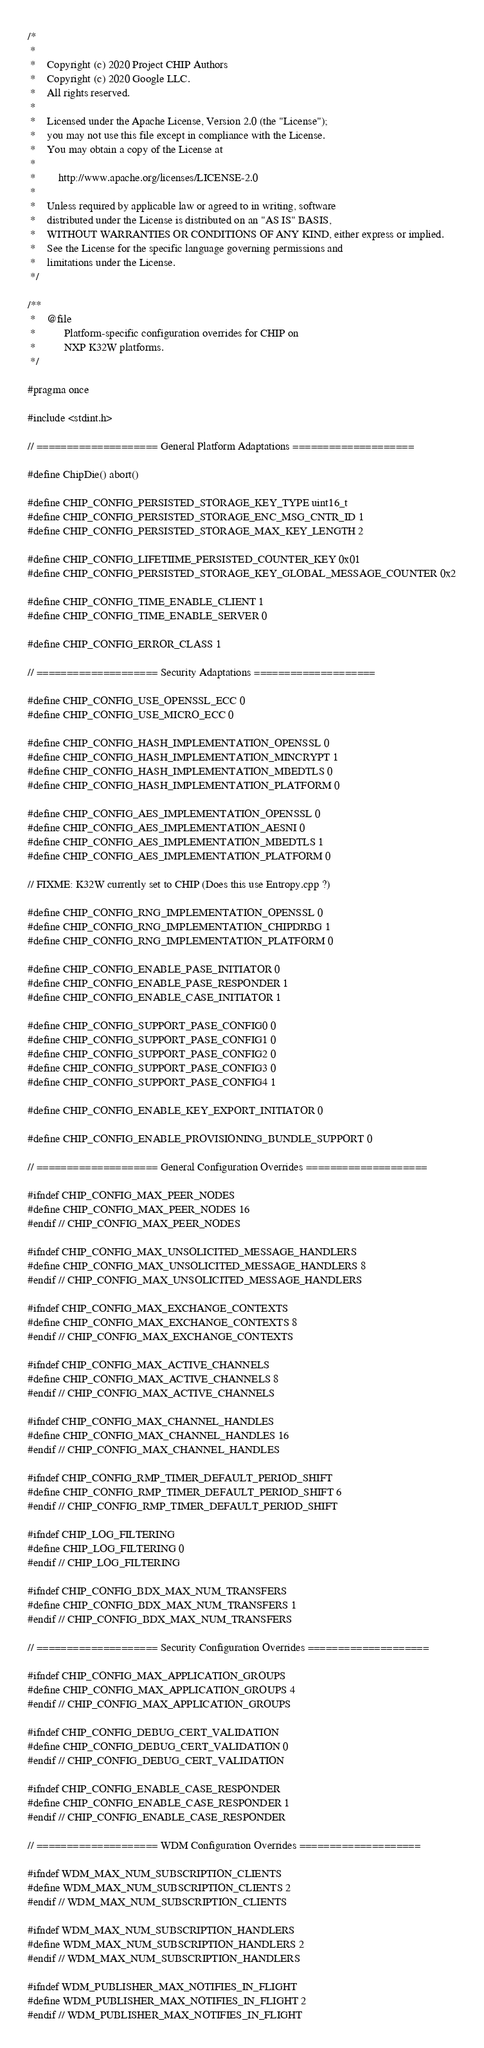<code> <loc_0><loc_0><loc_500><loc_500><_C_>/*
 *
 *    Copyright (c) 2020 Project CHIP Authors
 *    Copyright (c) 2020 Google LLC.
 *    All rights reserved.
 *
 *    Licensed under the Apache License, Version 2.0 (the "License");
 *    you may not use this file except in compliance with the License.
 *    You may obtain a copy of the License at
 *
 *        http://www.apache.org/licenses/LICENSE-2.0
 *
 *    Unless required by applicable law or agreed to in writing, software
 *    distributed under the License is distributed on an "AS IS" BASIS,
 *    WITHOUT WARRANTIES OR CONDITIONS OF ANY KIND, either express or implied.
 *    See the License for the specific language governing permissions and
 *    limitations under the License.
 */

/**
 *    @file
 *          Platform-specific configuration overrides for CHIP on
 *          NXP K32W platforms.
 */

#pragma once

#include <stdint.h>

// ==================== General Platform Adaptations ====================

#define ChipDie() abort()

#define CHIP_CONFIG_PERSISTED_STORAGE_KEY_TYPE uint16_t
#define CHIP_CONFIG_PERSISTED_STORAGE_ENC_MSG_CNTR_ID 1
#define CHIP_CONFIG_PERSISTED_STORAGE_MAX_KEY_LENGTH 2

#define CHIP_CONFIG_LIFETIIME_PERSISTED_COUNTER_KEY 0x01
#define CHIP_CONFIG_PERSISTED_STORAGE_KEY_GLOBAL_MESSAGE_COUNTER 0x2

#define CHIP_CONFIG_TIME_ENABLE_CLIENT 1
#define CHIP_CONFIG_TIME_ENABLE_SERVER 0

#define CHIP_CONFIG_ERROR_CLASS 1

// ==================== Security Adaptations ====================

#define CHIP_CONFIG_USE_OPENSSL_ECC 0
#define CHIP_CONFIG_USE_MICRO_ECC 0

#define CHIP_CONFIG_HASH_IMPLEMENTATION_OPENSSL 0
#define CHIP_CONFIG_HASH_IMPLEMENTATION_MINCRYPT 1
#define CHIP_CONFIG_HASH_IMPLEMENTATION_MBEDTLS 0
#define CHIP_CONFIG_HASH_IMPLEMENTATION_PLATFORM 0

#define CHIP_CONFIG_AES_IMPLEMENTATION_OPENSSL 0
#define CHIP_CONFIG_AES_IMPLEMENTATION_AESNI 0
#define CHIP_CONFIG_AES_IMPLEMENTATION_MBEDTLS 1
#define CHIP_CONFIG_AES_IMPLEMENTATION_PLATFORM 0

// FIXME: K32W currently set to CHIP (Does this use Entropy.cpp ?)

#define CHIP_CONFIG_RNG_IMPLEMENTATION_OPENSSL 0
#define CHIP_CONFIG_RNG_IMPLEMENTATION_CHIPDRBG 1
#define CHIP_CONFIG_RNG_IMPLEMENTATION_PLATFORM 0

#define CHIP_CONFIG_ENABLE_PASE_INITIATOR 0
#define CHIP_CONFIG_ENABLE_PASE_RESPONDER 1
#define CHIP_CONFIG_ENABLE_CASE_INITIATOR 1

#define CHIP_CONFIG_SUPPORT_PASE_CONFIG0 0
#define CHIP_CONFIG_SUPPORT_PASE_CONFIG1 0
#define CHIP_CONFIG_SUPPORT_PASE_CONFIG2 0
#define CHIP_CONFIG_SUPPORT_PASE_CONFIG3 0
#define CHIP_CONFIG_SUPPORT_PASE_CONFIG4 1

#define CHIP_CONFIG_ENABLE_KEY_EXPORT_INITIATOR 0

#define CHIP_CONFIG_ENABLE_PROVISIONING_BUNDLE_SUPPORT 0

// ==================== General Configuration Overrides ====================

#ifndef CHIP_CONFIG_MAX_PEER_NODES
#define CHIP_CONFIG_MAX_PEER_NODES 16
#endif // CHIP_CONFIG_MAX_PEER_NODES

#ifndef CHIP_CONFIG_MAX_UNSOLICITED_MESSAGE_HANDLERS
#define CHIP_CONFIG_MAX_UNSOLICITED_MESSAGE_HANDLERS 8
#endif // CHIP_CONFIG_MAX_UNSOLICITED_MESSAGE_HANDLERS

#ifndef CHIP_CONFIG_MAX_EXCHANGE_CONTEXTS
#define CHIP_CONFIG_MAX_EXCHANGE_CONTEXTS 8
#endif // CHIP_CONFIG_MAX_EXCHANGE_CONTEXTS

#ifndef CHIP_CONFIG_MAX_ACTIVE_CHANNELS
#define CHIP_CONFIG_MAX_ACTIVE_CHANNELS 8
#endif // CHIP_CONFIG_MAX_ACTIVE_CHANNELS

#ifndef CHIP_CONFIG_MAX_CHANNEL_HANDLES
#define CHIP_CONFIG_MAX_CHANNEL_HANDLES 16
#endif // CHIP_CONFIG_MAX_CHANNEL_HANDLES

#ifndef CHIP_CONFIG_RMP_TIMER_DEFAULT_PERIOD_SHIFT
#define CHIP_CONFIG_RMP_TIMER_DEFAULT_PERIOD_SHIFT 6
#endif // CHIP_CONFIG_RMP_TIMER_DEFAULT_PERIOD_SHIFT

#ifndef CHIP_LOG_FILTERING
#define CHIP_LOG_FILTERING 0
#endif // CHIP_LOG_FILTERING

#ifndef CHIP_CONFIG_BDX_MAX_NUM_TRANSFERS
#define CHIP_CONFIG_BDX_MAX_NUM_TRANSFERS 1
#endif // CHIP_CONFIG_BDX_MAX_NUM_TRANSFERS

// ==================== Security Configuration Overrides ====================

#ifndef CHIP_CONFIG_MAX_APPLICATION_GROUPS
#define CHIP_CONFIG_MAX_APPLICATION_GROUPS 4
#endif // CHIP_CONFIG_MAX_APPLICATION_GROUPS

#ifndef CHIP_CONFIG_DEBUG_CERT_VALIDATION
#define CHIP_CONFIG_DEBUG_CERT_VALIDATION 0
#endif // CHIP_CONFIG_DEBUG_CERT_VALIDATION

#ifndef CHIP_CONFIG_ENABLE_CASE_RESPONDER
#define CHIP_CONFIG_ENABLE_CASE_RESPONDER 1
#endif // CHIP_CONFIG_ENABLE_CASE_RESPONDER

// ==================== WDM Configuration Overrides ====================

#ifndef WDM_MAX_NUM_SUBSCRIPTION_CLIENTS
#define WDM_MAX_NUM_SUBSCRIPTION_CLIENTS 2
#endif // WDM_MAX_NUM_SUBSCRIPTION_CLIENTS

#ifndef WDM_MAX_NUM_SUBSCRIPTION_HANDLERS
#define WDM_MAX_NUM_SUBSCRIPTION_HANDLERS 2
#endif // WDM_MAX_NUM_SUBSCRIPTION_HANDLERS

#ifndef WDM_PUBLISHER_MAX_NOTIFIES_IN_FLIGHT
#define WDM_PUBLISHER_MAX_NOTIFIES_IN_FLIGHT 2
#endif // WDM_PUBLISHER_MAX_NOTIFIES_IN_FLIGHT
</code> 